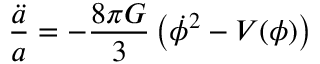Convert formula to latex. <formula><loc_0><loc_0><loc_500><loc_500>\frac { \ddot { a } } { a } = - \frac { 8 \pi G } { 3 } \left ( \dot { \phi } ^ { 2 } - V ( \phi ) \right )</formula> 